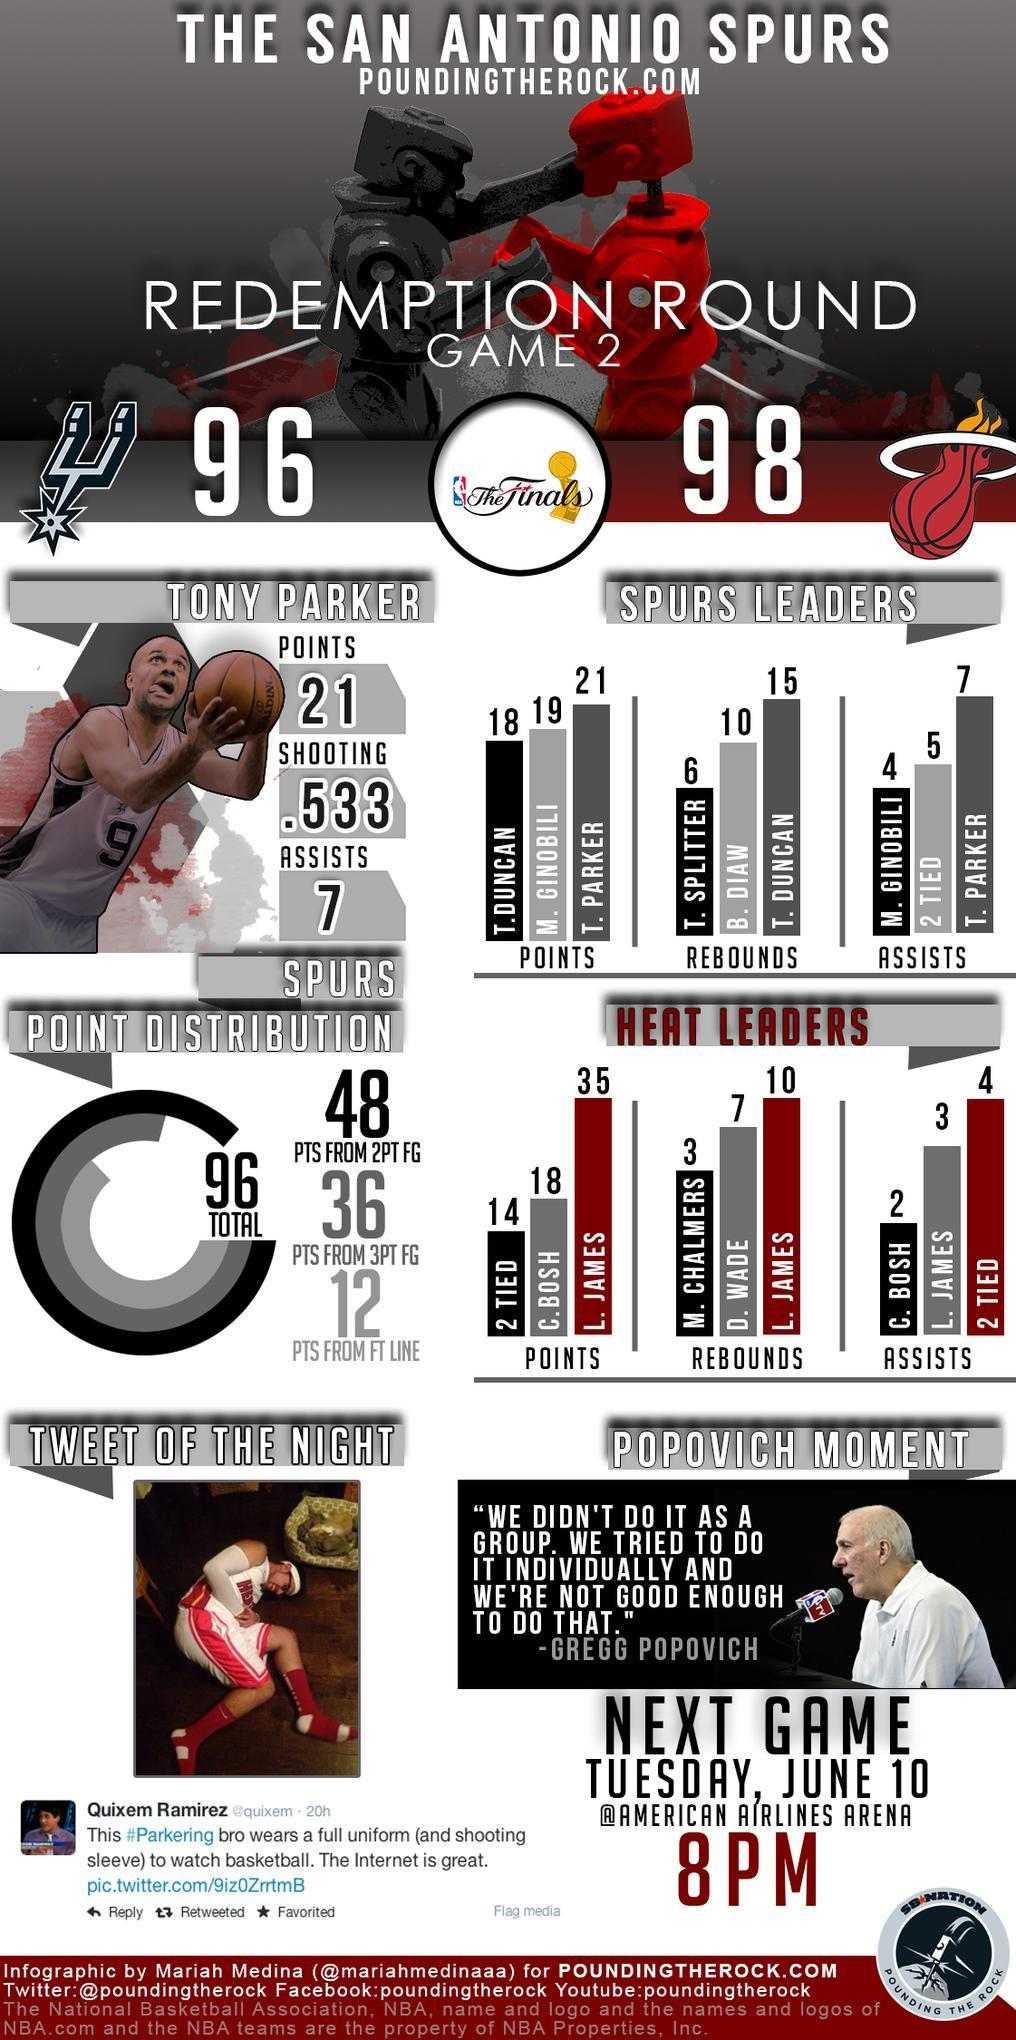How many rebounds from B. Dian and T. Duncan, taken together from Spurs Leaders?
Answer the question with a short phrase. 25 What is the number of Assists from Tony Parker? 7 How many points from T. Parker and T. Duncan, taken together from Spurs Leaders? 39 How many points from Tony Parker? 21 How many Assists from T. Parker and 2 Tied, taken together from Spurs Leaders ? 12 